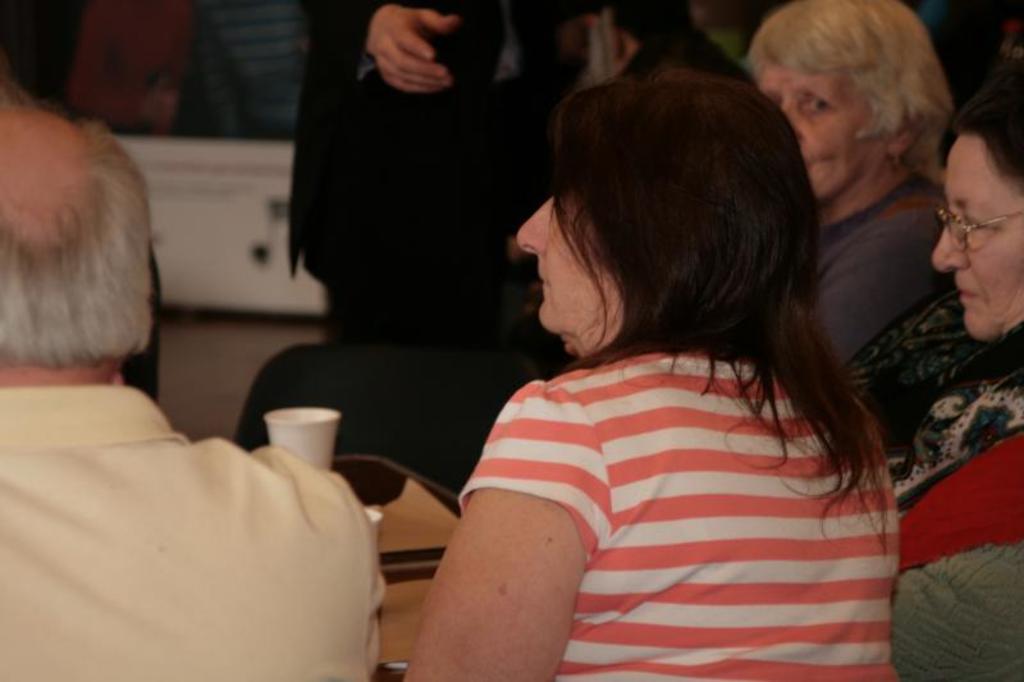How would you summarize this image in a sentence or two? In this image I can see few people sitting and looking at the left side. In front of these people there is a table on which two gases are placed. In the background there is another table placed on the floor. 